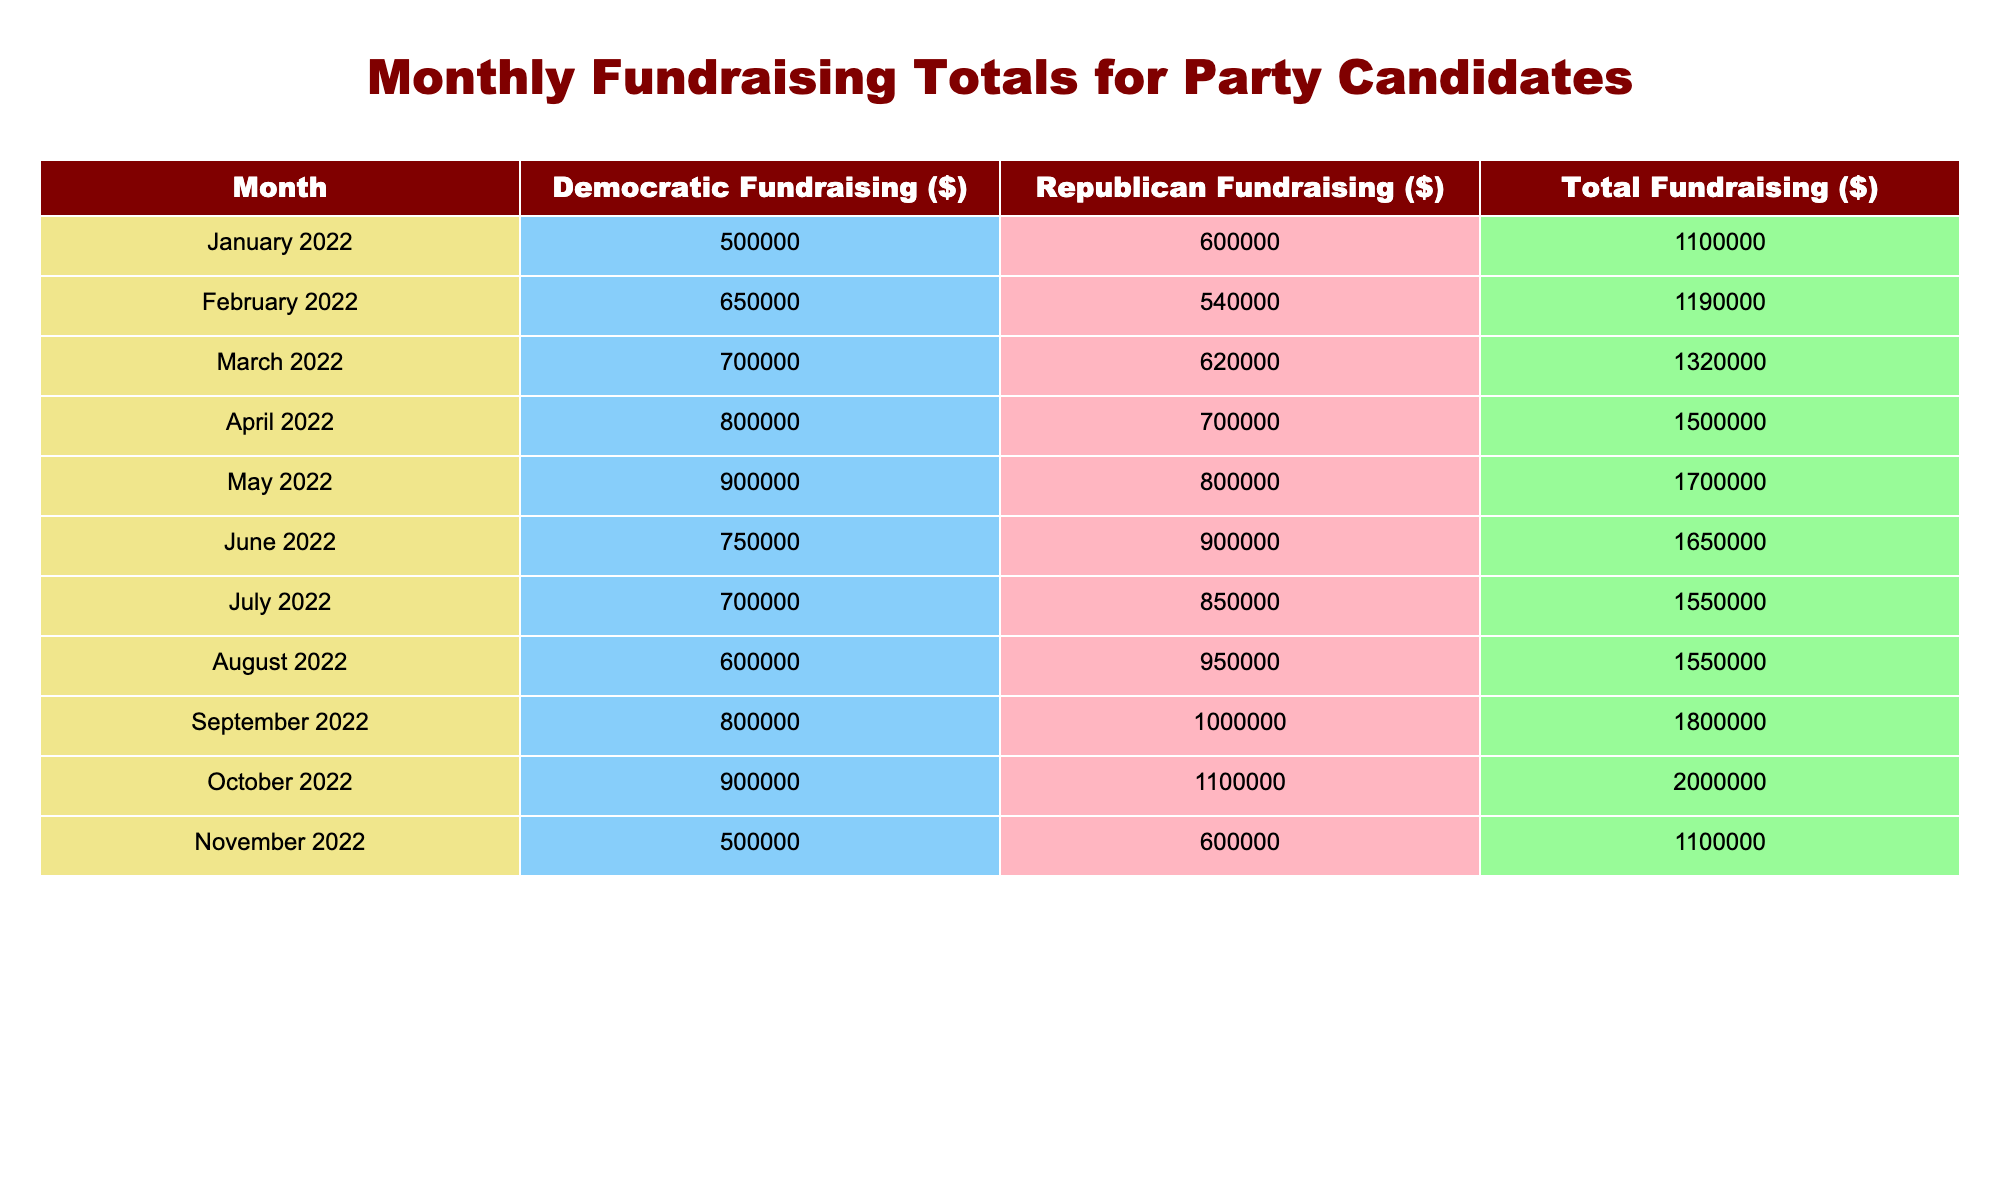What was the total fundraising amount in March 2022? The table shows that in March 2022, the total fundraising amount was listed as $1,320,000.
Answer: $1,320,000 Which party raised more funds in June 2022? In June 2022, the Democratic Party raised $750,000, while the Republican Party raised $900,000. Since $900,000 is greater than $750,000, the Republican Party raised more funds.
Answer: Republican Party What is the average total fundraising amount across all months listed? To find the average total fundraising, sum up all total amounts: $1,100,000 + $1,190,000 + $1,320,000 + $1,500,000 + $1,700,000 + $1,650,000 + $1,550,000 + $1,550,000 + $1,800,000 + $2,000,000 + $1,100,000 = $17,510,000. There are 11 months, so the average is $17,510,000 / 11 = $1,591,818.18, which can be rounded to $1,591,818.
Answer: $1,591,818 Did the Democratic Party's fundraising increase every month from January to November 2022? By inspecting the amounts for each month, we see the Democratic Party raised $500,000 in January, $650,000 in February, $700,000 in March, $800,000 in April, $900,000 in May, $750,000 in June, $700,000 in July, $600,000 in August, $800,000 in September, $900,000 in October, and $500,000 in November. There are decreases in June, July, August, and November; therefore, the answer is no, their fundraising did not increase every month.
Answer: No What was the percentage increase in total fundraising from January 2022 to October 2022? The total fundraising in January 2022 was $1,100,000 and in October 2022 was $2,000,000. The difference is $2,000,000 - $1,100,000 = $900,000. The percentage increase is calculated as ($900,000 / $1,100,000) * 100% = 81.82%.
Answer: 81.82% 